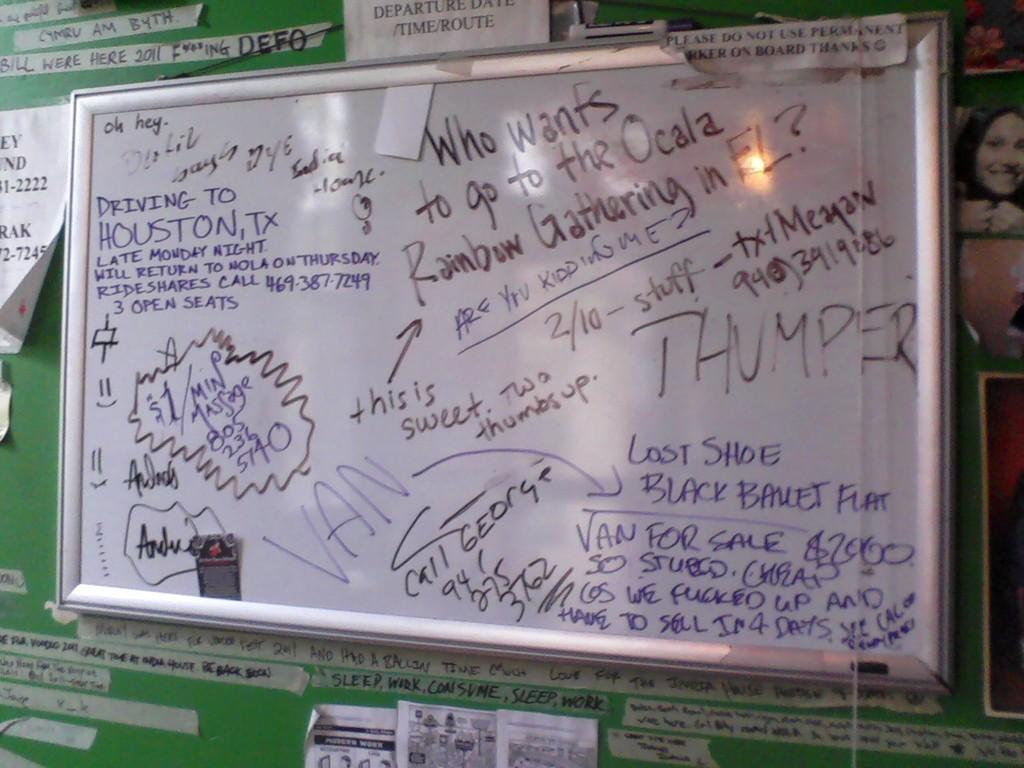Please provide a concise description of this image. There is a board with something written on that. In the back there is a green wall with posters. On the right side there is an image of a lady. 